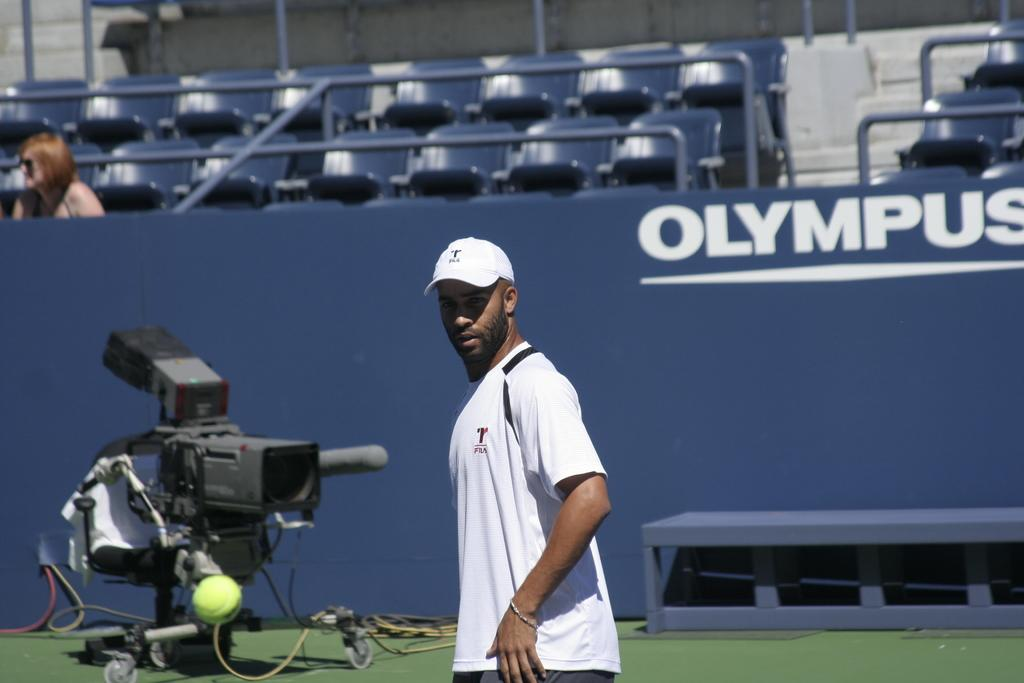Provide a one-sentence caption for the provided image. A tennis player passes by an Olympus advertisement on the court's wall. 